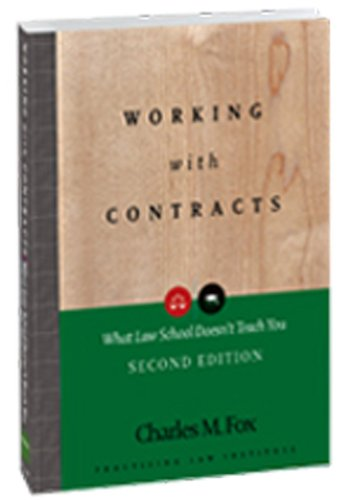Who is the target audience for this book? The target audience includes law students who are eager to gain practical skills not typically taught in classrooms, as well as practicing lawyers who seek a deeper understanding of contract law. How does this book benefit law students differently compared to traditional textbooks? Unlike traditional textbooks, which often focus on theoretical aspects of law, this book provides actionable insights and real-world applications that prepare students for actual legal practice, particularly in negotiating and managing contracts. 